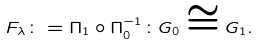Convert formula to latex. <formula><loc_0><loc_0><loc_500><loc_500>F _ { \lambda } \colon = \Pi _ { 1 } \circ \Pi _ { 0 } ^ { - 1 } \colon G _ { 0 } \cong G _ { 1 } .</formula> 